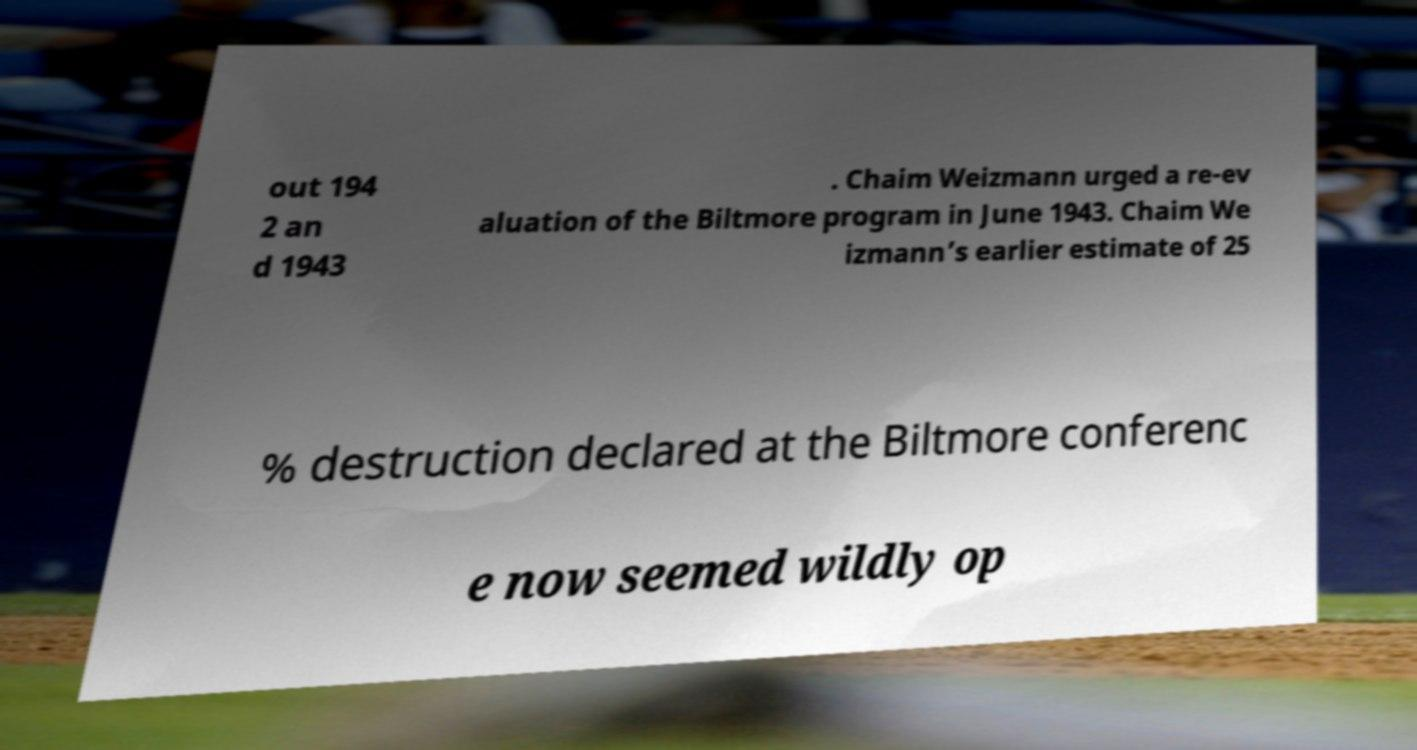Please read and relay the text visible in this image. What does it say? out 194 2 an d 1943 . Chaim Weizmann urged a re-ev aluation of the Biltmore program in June 1943. Chaim We izmann’s earlier estimate of 25 % destruction declared at the Biltmore conferenc e now seemed wildly op 